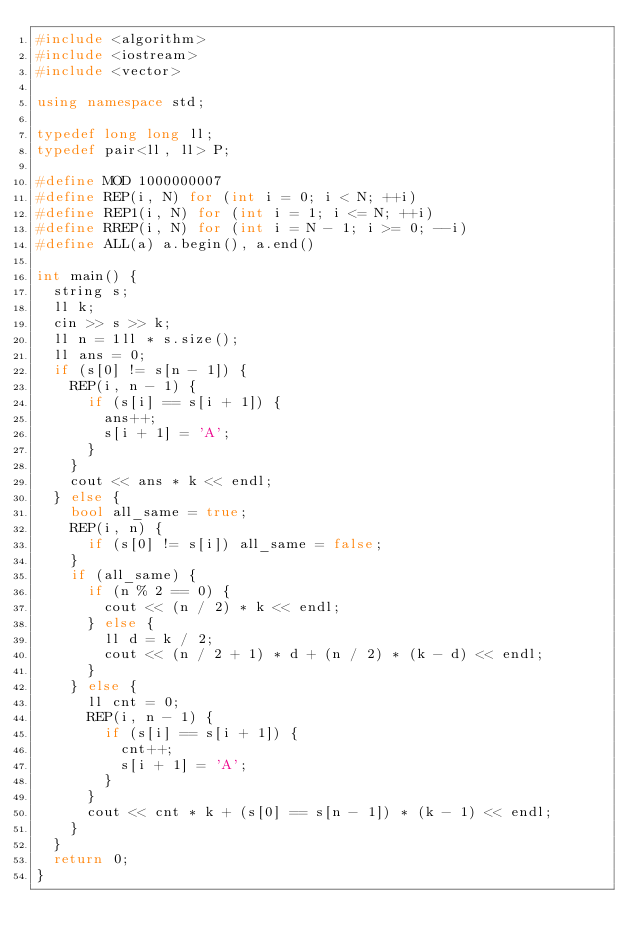<code> <loc_0><loc_0><loc_500><loc_500><_C++_>#include <algorithm>
#include <iostream>
#include <vector>

using namespace std;

typedef long long ll;
typedef pair<ll, ll> P;

#define MOD 1000000007
#define REP(i, N) for (int i = 0; i < N; ++i)
#define REP1(i, N) for (int i = 1; i <= N; ++i)
#define RREP(i, N) for (int i = N - 1; i >= 0; --i)
#define ALL(a) a.begin(), a.end()

int main() {
  string s;
  ll k;
  cin >> s >> k;
  ll n = 1ll * s.size();
  ll ans = 0;
  if (s[0] != s[n - 1]) {
    REP(i, n - 1) {
      if (s[i] == s[i + 1]) {
        ans++;
        s[i + 1] = 'A';
      }
    }
    cout << ans * k << endl;
  } else {
    bool all_same = true;
    REP(i, n) {
      if (s[0] != s[i]) all_same = false;
    }
    if (all_same) {
      if (n % 2 == 0) {
        cout << (n / 2) * k << endl;
      } else {
        ll d = k / 2;
        cout << (n / 2 + 1) * d + (n / 2) * (k - d) << endl;
      }
    } else {
      ll cnt = 0;
      REP(i, n - 1) {
        if (s[i] == s[i + 1]) {
          cnt++;
          s[i + 1] = 'A';
        }
      }
      cout << cnt * k + (s[0] == s[n - 1]) * (k - 1) << endl;
    }
  }
  return 0;
}</code> 